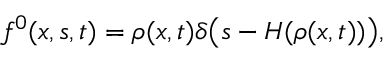Convert formula to latex. <formula><loc_0><loc_0><loc_500><loc_500>f ^ { 0 } ( x , s , t ) = \rho ( x , t ) \delta \left ( s - H ( \rho ( x , t ) ) \right ) ,</formula> 